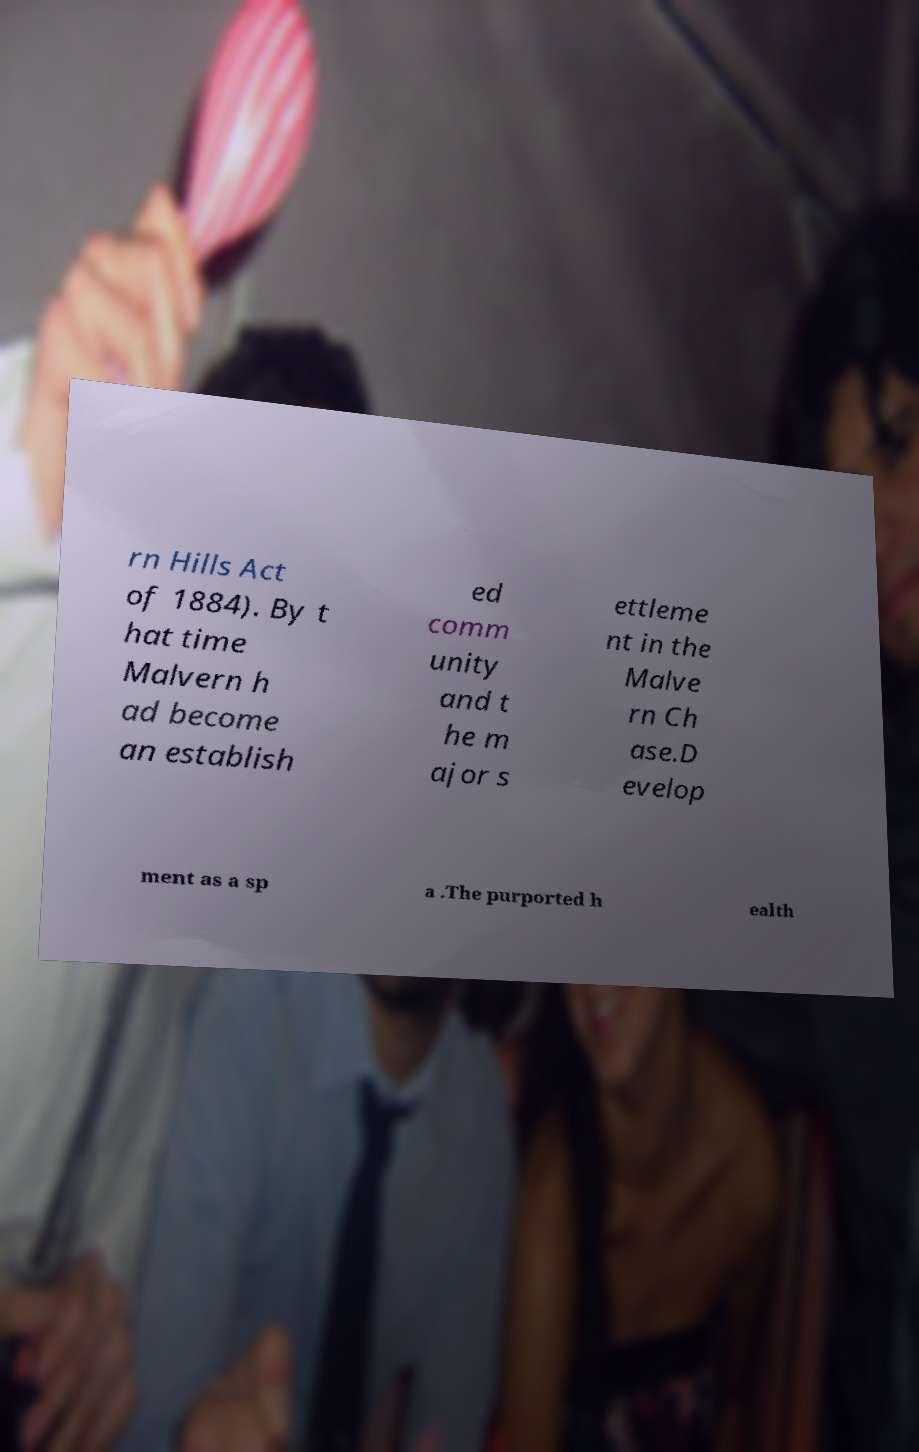What messages or text are displayed in this image? I need them in a readable, typed format. rn Hills Act of 1884). By t hat time Malvern h ad become an establish ed comm unity and t he m ajor s ettleme nt in the Malve rn Ch ase.D evelop ment as a sp a .The purported h ealth 